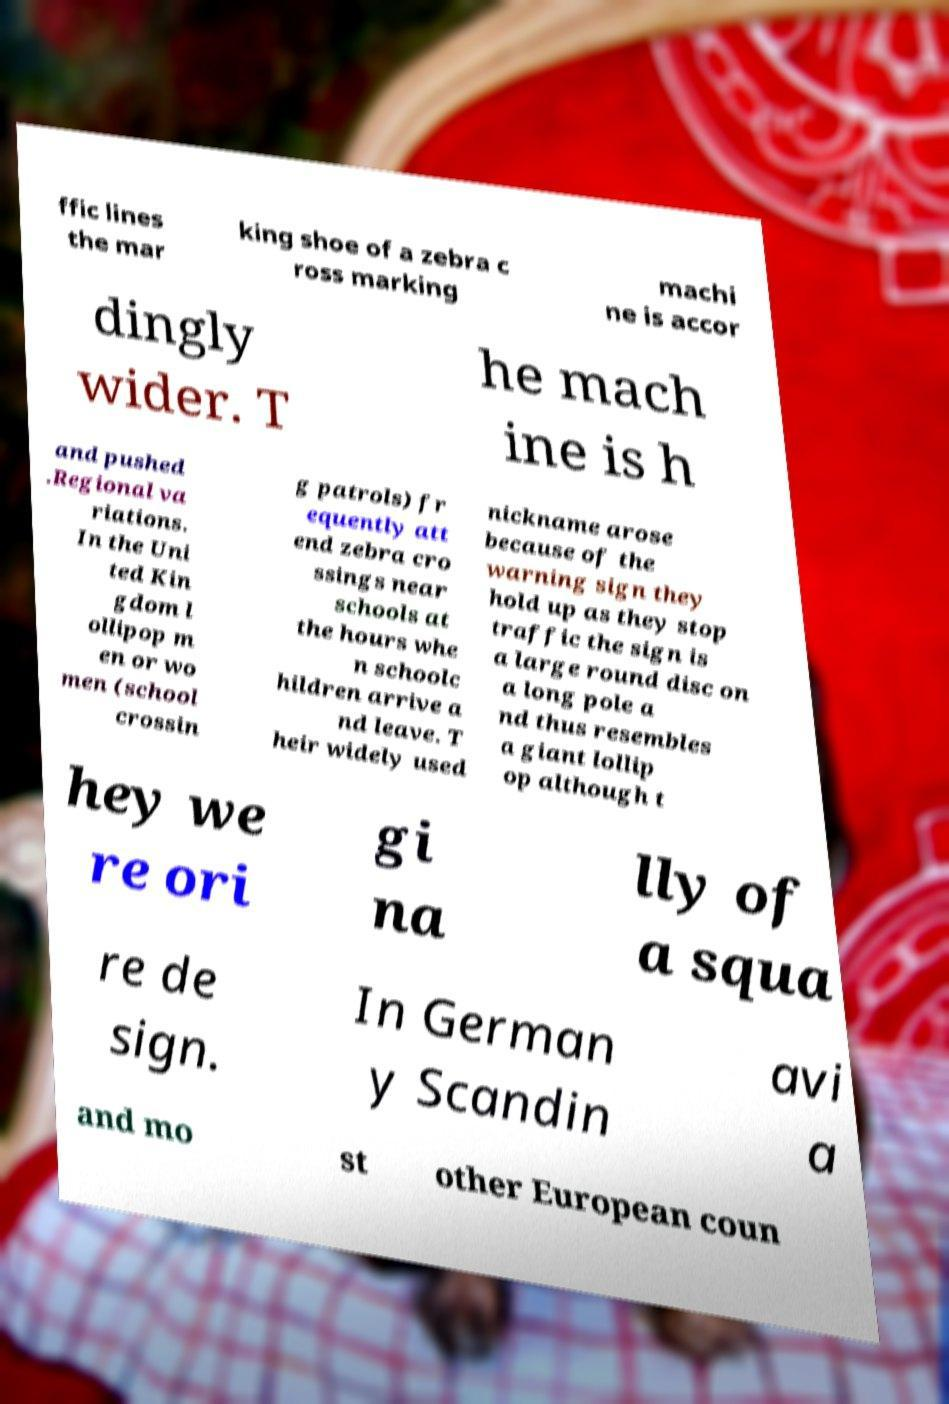Please read and relay the text visible in this image. What does it say? ffic lines the mar king shoe of a zebra c ross marking machi ne is accor dingly wider. T he mach ine is h and pushed .Regional va riations. In the Uni ted Kin gdom l ollipop m en or wo men (school crossin g patrols) fr equently att end zebra cro ssings near schools at the hours whe n schoolc hildren arrive a nd leave. T heir widely used nickname arose because of the warning sign they hold up as they stop traffic the sign is a large round disc on a long pole a nd thus resembles a giant lollip op although t hey we re ori gi na lly of a squa re de sign. In German y Scandin avi a and mo st other European coun 